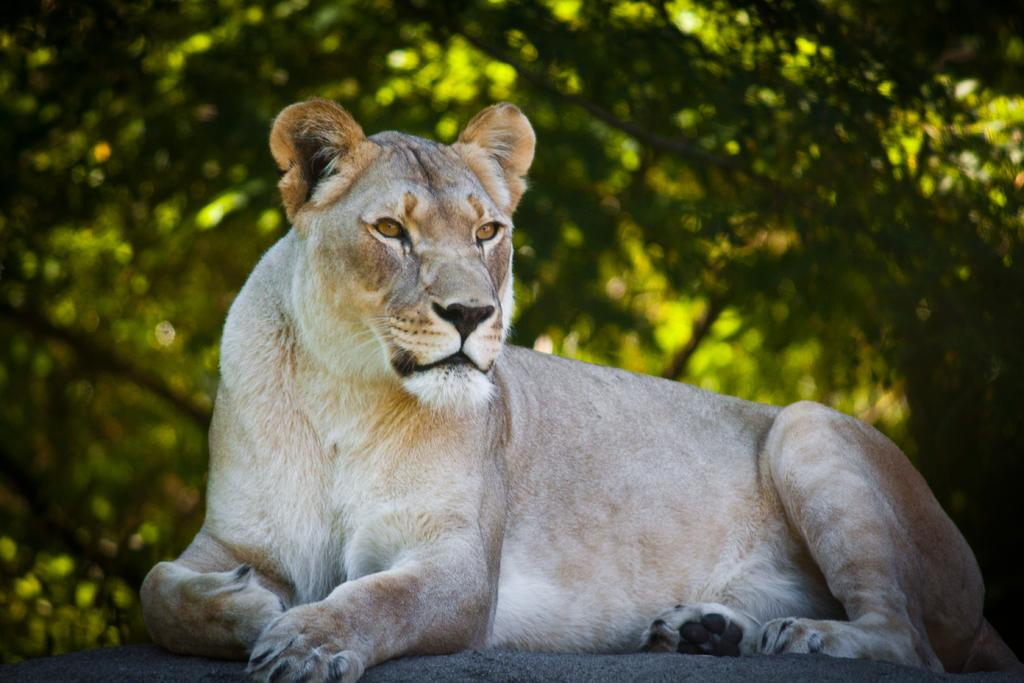What animal is the main subject of the image? There is a lion in the image. What is the lion doing in the image? The lion is looking at something. Can you describe the background of the image? The background of the image is blurred. What type of tomatoes can be seen growing in the background of the image? There are no tomatoes present in the image; the background is blurred. Can you describe the ray of light shining on the lion in the image? There is no ray of light shining on the lion in the image; the background is blurred, and the focus is on the lion itself. 